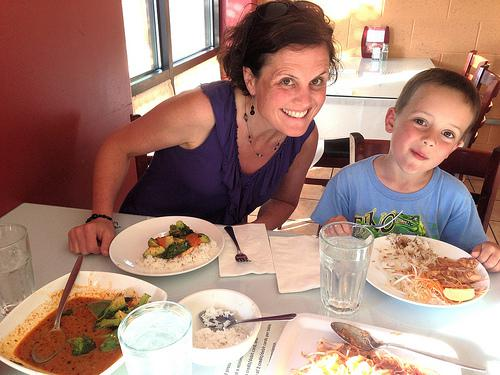Question: what animal is on the boy's shirt?
Choices:
A. A lion.
B. A lizard.
C. A dinosaur.
D. A elephant.
Answer with the letter. Answer: C Question: who is sitting next to the woman?
Choices:
A. A teenager.
B. A husband.
C. A toddler.
D. A boy.
Answer with the letter. Answer: D Question: what is in the drinking glasses?
Choices:
A. Soda.
B. Vodka.
C. Water.
D. Tea.
Answer with the letter. Answer: C Question: who is eating rice and vegetables?
Choices:
A. The woman.
B. The coworker.
C. The teenager.
D. The grandmother.
Answer with the letter. Answer: A Question: what color is the woman's shirt?
Choices:
A. Red.
B. Green.
C. Purple.
D. Blue.
Answer with the letter. Answer: C 